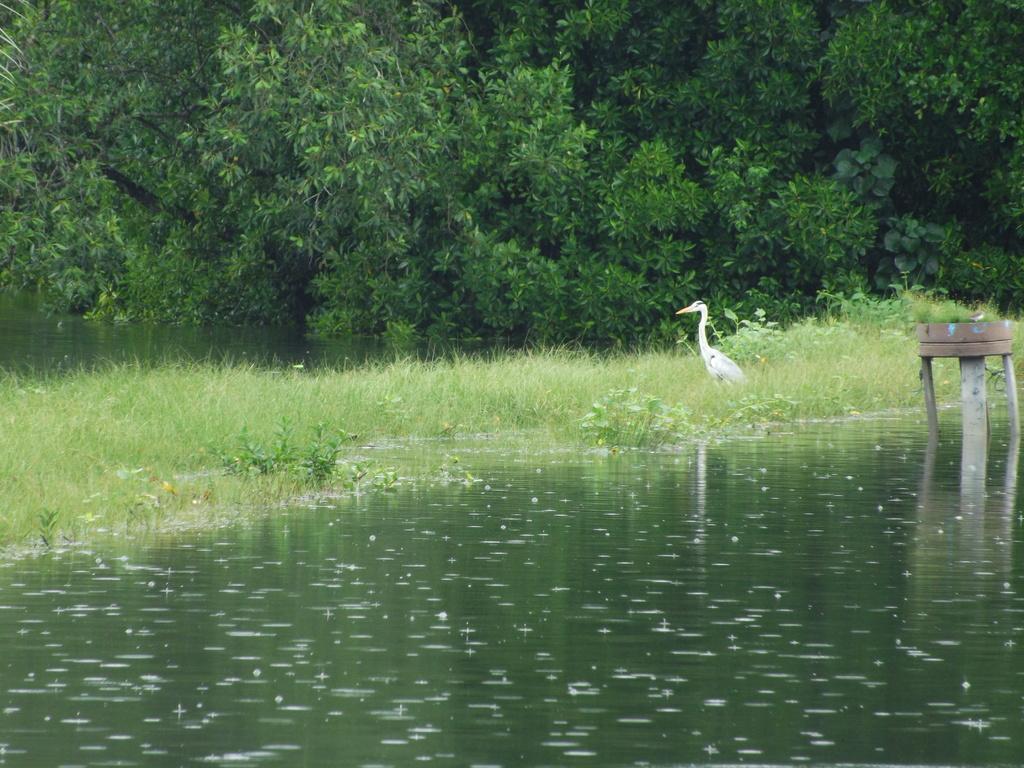Describe this image in one or two sentences. At the bottom of this image I can see the water. In the right side there is a wooden object. In the middle of the image I can see the grass and there is a bird. In the background there are some trees. 